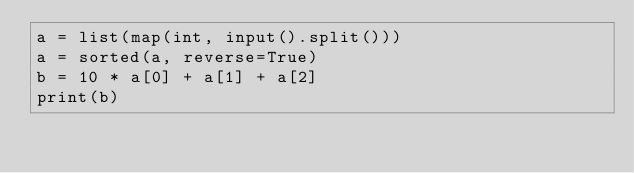<code> <loc_0><loc_0><loc_500><loc_500><_Python_>a = list(map(int, input().split()))
a = sorted(a, reverse=True)
b = 10 * a[0] + a[1] + a[2]
print(b)
</code> 